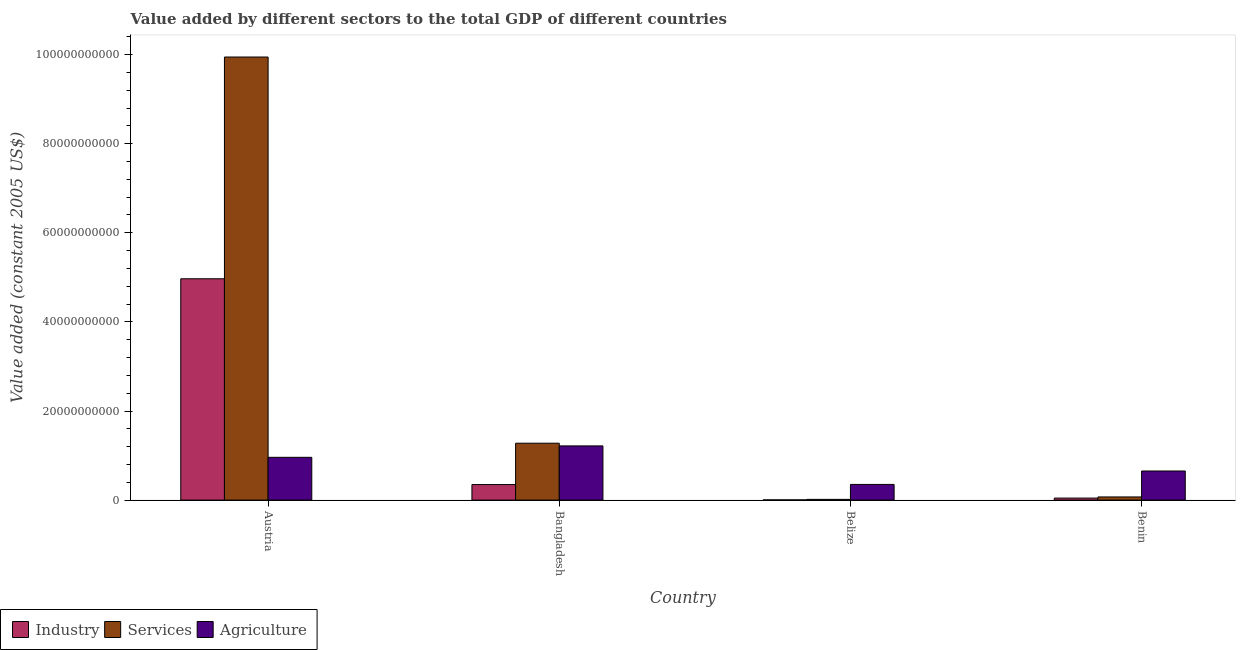Are the number of bars per tick equal to the number of legend labels?
Make the answer very short. Yes. How many bars are there on the 1st tick from the right?
Your answer should be very brief. 3. In how many cases, is the number of bars for a given country not equal to the number of legend labels?
Give a very brief answer. 0. What is the value added by agricultural sector in Austria?
Your answer should be compact. 9.60e+09. Across all countries, what is the maximum value added by industrial sector?
Your answer should be very brief. 4.97e+1. Across all countries, what is the minimum value added by services?
Ensure brevity in your answer.  1.61e+08. In which country was the value added by agricultural sector minimum?
Offer a very short reply. Belize. What is the total value added by agricultural sector in the graph?
Ensure brevity in your answer.  3.18e+1. What is the difference between the value added by agricultural sector in Bangladesh and that in Belize?
Provide a short and direct response. 8.64e+09. What is the difference between the value added by services in Belize and the value added by agricultural sector in Austria?
Offer a very short reply. -9.44e+09. What is the average value added by services per country?
Your response must be concise. 2.83e+1. What is the difference between the value added by industrial sector and value added by agricultural sector in Bangladesh?
Keep it short and to the point. -8.68e+09. In how many countries, is the value added by industrial sector greater than 80000000000 US$?
Provide a succinct answer. 0. What is the ratio of the value added by industrial sector in Belize to that in Benin?
Provide a short and direct response. 0.1. Is the value added by services in Austria less than that in Bangladesh?
Provide a succinct answer. No. Is the difference between the value added by services in Austria and Benin greater than the difference between the value added by industrial sector in Austria and Benin?
Provide a short and direct response. Yes. What is the difference between the highest and the second highest value added by agricultural sector?
Keep it short and to the point. 2.56e+09. What is the difference between the highest and the lowest value added by services?
Ensure brevity in your answer.  9.93e+1. Is the sum of the value added by services in Austria and Benin greater than the maximum value added by agricultural sector across all countries?
Keep it short and to the point. Yes. What does the 3rd bar from the left in Austria represents?
Give a very brief answer. Agriculture. What does the 1st bar from the right in Austria represents?
Give a very brief answer. Agriculture. Is it the case that in every country, the sum of the value added by industrial sector and value added by services is greater than the value added by agricultural sector?
Your response must be concise. No. How many bars are there?
Your response must be concise. 12. Are the values on the major ticks of Y-axis written in scientific E-notation?
Make the answer very short. No. Does the graph contain any zero values?
Ensure brevity in your answer.  No. Where does the legend appear in the graph?
Offer a very short reply. Bottom left. How many legend labels are there?
Your answer should be compact. 3. How are the legend labels stacked?
Offer a very short reply. Horizontal. What is the title of the graph?
Your response must be concise. Value added by different sectors to the total GDP of different countries. What is the label or title of the X-axis?
Your answer should be very brief. Country. What is the label or title of the Y-axis?
Ensure brevity in your answer.  Value added (constant 2005 US$). What is the Value added (constant 2005 US$) in Industry in Austria?
Provide a short and direct response. 4.97e+1. What is the Value added (constant 2005 US$) in Services in Austria?
Your answer should be very brief. 9.95e+1. What is the Value added (constant 2005 US$) in Agriculture in Austria?
Keep it short and to the point. 9.60e+09. What is the Value added (constant 2005 US$) in Industry in Bangladesh?
Offer a terse response. 3.48e+09. What is the Value added (constant 2005 US$) of Services in Bangladesh?
Keep it short and to the point. 1.28e+1. What is the Value added (constant 2005 US$) in Agriculture in Bangladesh?
Make the answer very short. 1.22e+1. What is the Value added (constant 2005 US$) in Industry in Belize?
Your answer should be very brief. 4.64e+07. What is the Value added (constant 2005 US$) of Services in Belize?
Make the answer very short. 1.61e+08. What is the Value added (constant 2005 US$) in Agriculture in Belize?
Ensure brevity in your answer.  3.52e+09. What is the Value added (constant 2005 US$) in Industry in Benin?
Make the answer very short. 4.52e+08. What is the Value added (constant 2005 US$) of Services in Benin?
Provide a succinct answer. 7.09e+08. What is the Value added (constant 2005 US$) in Agriculture in Benin?
Offer a terse response. 6.53e+09. Across all countries, what is the maximum Value added (constant 2005 US$) of Industry?
Offer a very short reply. 4.97e+1. Across all countries, what is the maximum Value added (constant 2005 US$) in Services?
Your answer should be very brief. 9.95e+1. Across all countries, what is the maximum Value added (constant 2005 US$) of Agriculture?
Give a very brief answer. 1.22e+1. Across all countries, what is the minimum Value added (constant 2005 US$) in Industry?
Your answer should be compact. 4.64e+07. Across all countries, what is the minimum Value added (constant 2005 US$) in Services?
Offer a terse response. 1.61e+08. Across all countries, what is the minimum Value added (constant 2005 US$) in Agriculture?
Make the answer very short. 3.52e+09. What is the total Value added (constant 2005 US$) of Industry in the graph?
Keep it short and to the point. 5.37e+1. What is the total Value added (constant 2005 US$) in Services in the graph?
Provide a succinct answer. 1.13e+11. What is the total Value added (constant 2005 US$) of Agriculture in the graph?
Keep it short and to the point. 3.18e+1. What is the difference between the Value added (constant 2005 US$) of Industry in Austria and that in Bangladesh?
Ensure brevity in your answer.  4.62e+1. What is the difference between the Value added (constant 2005 US$) in Services in Austria and that in Bangladesh?
Provide a short and direct response. 8.67e+1. What is the difference between the Value added (constant 2005 US$) in Agriculture in Austria and that in Bangladesh?
Offer a very short reply. -2.56e+09. What is the difference between the Value added (constant 2005 US$) in Industry in Austria and that in Belize?
Offer a very short reply. 4.96e+1. What is the difference between the Value added (constant 2005 US$) of Services in Austria and that in Belize?
Offer a very short reply. 9.93e+1. What is the difference between the Value added (constant 2005 US$) of Agriculture in Austria and that in Belize?
Ensure brevity in your answer.  6.08e+09. What is the difference between the Value added (constant 2005 US$) of Industry in Austria and that in Benin?
Your response must be concise. 4.92e+1. What is the difference between the Value added (constant 2005 US$) of Services in Austria and that in Benin?
Make the answer very short. 9.87e+1. What is the difference between the Value added (constant 2005 US$) of Agriculture in Austria and that in Benin?
Offer a very short reply. 3.07e+09. What is the difference between the Value added (constant 2005 US$) in Industry in Bangladesh and that in Belize?
Provide a short and direct response. 3.44e+09. What is the difference between the Value added (constant 2005 US$) of Services in Bangladesh and that in Belize?
Keep it short and to the point. 1.26e+1. What is the difference between the Value added (constant 2005 US$) of Agriculture in Bangladesh and that in Belize?
Ensure brevity in your answer.  8.64e+09. What is the difference between the Value added (constant 2005 US$) in Industry in Bangladesh and that in Benin?
Provide a succinct answer. 3.03e+09. What is the difference between the Value added (constant 2005 US$) of Services in Bangladesh and that in Benin?
Ensure brevity in your answer.  1.21e+1. What is the difference between the Value added (constant 2005 US$) of Agriculture in Bangladesh and that in Benin?
Provide a succinct answer. 5.63e+09. What is the difference between the Value added (constant 2005 US$) of Industry in Belize and that in Benin?
Provide a succinct answer. -4.05e+08. What is the difference between the Value added (constant 2005 US$) of Services in Belize and that in Benin?
Keep it short and to the point. -5.48e+08. What is the difference between the Value added (constant 2005 US$) in Agriculture in Belize and that in Benin?
Provide a succinct answer. -3.01e+09. What is the difference between the Value added (constant 2005 US$) of Industry in Austria and the Value added (constant 2005 US$) of Services in Bangladesh?
Offer a very short reply. 3.69e+1. What is the difference between the Value added (constant 2005 US$) of Industry in Austria and the Value added (constant 2005 US$) of Agriculture in Bangladesh?
Offer a terse response. 3.75e+1. What is the difference between the Value added (constant 2005 US$) of Services in Austria and the Value added (constant 2005 US$) of Agriculture in Bangladesh?
Your response must be concise. 8.73e+1. What is the difference between the Value added (constant 2005 US$) of Industry in Austria and the Value added (constant 2005 US$) of Services in Belize?
Keep it short and to the point. 4.95e+1. What is the difference between the Value added (constant 2005 US$) in Industry in Austria and the Value added (constant 2005 US$) in Agriculture in Belize?
Your answer should be very brief. 4.62e+1. What is the difference between the Value added (constant 2005 US$) of Services in Austria and the Value added (constant 2005 US$) of Agriculture in Belize?
Give a very brief answer. 9.59e+1. What is the difference between the Value added (constant 2005 US$) of Industry in Austria and the Value added (constant 2005 US$) of Services in Benin?
Your answer should be compact. 4.90e+1. What is the difference between the Value added (constant 2005 US$) in Industry in Austria and the Value added (constant 2005 US$) in Agriculture in Benin?
Provide a succinct answer. 4.31e+1. What is the difference between the Value added (constant 2005 US$) in Services in Austria and the Value added (constant 2005 US$) in Agriculture in Benin?
Offer a very short reply. 9.29e+1. What is the difference between the Value added (constant 2005 US$) in Industry in Bangladesh and the Value added (constant 2005 US$) in Services in Belize?
Keep it short and to the point. 3.32e+09. What is the difference between the Value added (constant 2005 US$) of Industry in Bangladesh and the Value added (constant 2005 US$) of Agriculture in Belize?
Your answer should be very brief. -3.68e+07. What is the difference between the Value added (constant 2005 US$) in Services in Bangladesh and the Value added (constant 2005 US$) in Agriculture in Belize?
Your answer should be very brief. 9.25e+09. What is the difference between the Value added (constant 2005 US$) of Industry in Bangladesh and the Value added (constant 2005 US$) of Services in Benin?
Offer a terse response. 2.78e+09. What is the difference between the Value added (constant 2005 US$) in Industry in Bangladesh and the Value added (constant 2005 US$) in Agriculture in Benin?
Offer a terse response. -3.05e+09. What is the difference between the Value added (constant 2005 US$) in Services in Bangladesh and the Value added (constant 2005 US$) in Agriculture in Benin?
Provide a succinct answer. 6.24e+09. What is the difference between the Value added (constant 2005 US$) of Industry in Belize and the Value added (constant 2005 US$) of Services in Benin?
Your answer should be compact. -6.63e+08. What is the difference between the Value added (constant 2005 US$) of Industry in Belize and the Value added (constant 2005 US$) of Agriculture in Benin?
Offer a terse response. -6.49e+09. What is the difference between the Value added (constant 2005 US$) of Services in Belize and the Value added (constant 2005 US$) of Agriculture in Benin?
Ensure brevity in your answer.  -6.37e+09. What is the average Value added (constant 2005 US$) of Industry per country?
Provide a succinct answer. 1.34e+1. What is the average Value added (constant 2005 US$) of Services per country?
Give a very brief answer. 2.83e+1. What is the average Value added (constant 2005 US$) of Agriculture per country?
Your answer should be very brief. 7.96e+09. What is the difference between the Value added (constant 2005 US$) of Industry and Value added (constant 2005 US$) of Services in Austria?
Offer a very short reply. -4.98e+1. What is the difference between the Value added (constant 2005 US$) in Industry and Value added (constant 2005 US$) in Agriculture in Austria?
Provide a succinct answer. 4.01e+1. What is the difference between the Value added (constant 2005 US$) of Services and Value added (constant 2005 US$) of Agriculture in Austria?
Give a very brief answer. 8.99e+1. What is the difference between the Value added (constant 2005 US$) of Industry and Value added (constant 2005 US$) of Services in Bangladesh?
Your response must be concise. -9.28e+09. What is the difference between the Value added (constant 2005 US$) in Industry and Value added (constant 2005 US$) in Agriculture in Bangladesh?
Offer a very short reply. -8.68e+09. What is the difference between the Value added (constant 2005 US$) of Services and Value added (constant 2005 US$) of Agriculture in Bangladesh?
Give a very brief answer. 6.04e+08. What is the difference between the Value added (constant 2005 US$) of Industry and Value added (constant 2005 US$) of Services in Belize?
Your answer should be very brief. -1.14e+08. What is the difference between the Value added (constant 2005 US$) of Industry and Value added (constant 2005 US$) of Agriculture in Belize?
Keep it short and to the point. -3.47e+09. What is the difference between the Value added (constant 2005 US$) in Services and Value added (constant 2005 US$) in Agriculture in Belize?
Your response must be concise. -3.36e+09. What is the difference between the Value added (constant 2005 US$) in Industry and Value added (constant 2005 US$) in Services in Benin?
Your answer should be compact. -2.58e+08. What is the difference between the Value added (constant 2005 US$) in Industry and Value added (constant 2005 US$) in Agriculture in Benin?
Provide a short and direct response. -6.08e+09. What is the difference between the Value added (constant 2005 US$) of Services and Value added (constant 2005 US$) of Agriculture in Benin?
Provide a succinct answer. -5.82e+09. What is the ratio of the Value added (constant 2005 US$) of Industry in Austria to that in Bangladesh?
Provide a short and direct response. 14.26. What is the ratio of the Value added (constant 2005 US$) in Services in Austria to that in Bangladesh?
Offer a terse response. 7.79. What is the ratio of the Value added (constant 2005 US$) in Agriculture in Austria to that in Bangladesh?
Offer a very short reply. 0.79. What is the ratio of the Value added (constant 2005 US$) of Industry in Austria to that in Belize?
Make the answer very short. 1071.1. What is the ratio of the Value added (constant 2005 US$) of Services in Austria to that in Belize?
Provide a succinct answer. 618.78. What is the ratio of the Value added (constant 2005 US$) of Agriculture in Austria to that in Belize?
Offer a very short reply. 2.73. What is the ratio of the Value added (constant 2005 US$) in Industry in Austria to that in Benin?
Offer a terse response. 110.02. What is the ratio of the Value added (constant 2005 US$) of Services in Austria to that in Benin?
Make the answer very short. 140.25. What is the ratio of the Value added (constant 2005 US$) of Agriculture in Austria to that in Benin?
Offer a very short reply. 1.47. What is the ratio of the Value added (constant 2005 US$) of Industry in Bangladesh to that in Belize?
Offer a very short reply. 75.12. What is the ratio of the Value added (constant 2005 US$) in Services in Bangladesh to that in Belize?
Your response must be concise. 79.44. What is the ratio of the Value added (constant 2005 US$) in Agriculture in Bangladesh to that in Belize?
Your answer should be very brief. 3.45. What is the ratio of the Value added (constant 2005 US$) of Industry in Bangladesh to that in Benin?
Provide a short and direct response. 7.72. What is the ratio of the Value added (constant 2005 US$) in Services in Bangladesh to that in Benin?
Provide a short and direct response. 18.01. What is the ratio of the Value added (constant 2005 US$) in Agriculture in Bangladesh to that in Benin?
Your answer should be very brief. 1.86. What is the ratio of the Value added (constant 2005 US$) in Industry in Belize to that in Benin?
Your response must be concise. 0.1. What is the ratio of the Value added (constant 2005 US$) in Services in Belize to that in Benin?
Your answer should be very brief. 0.23. What is the ratio of the Value added (constant 2005 US$) of Agriculture in Belize to that in Benin?
Your answer should be compact. 0.54. What is the difference between the highest and the second highest Value added (constant 2005 US$) in Industry?
Make the answer very short. 4.62e+1. What is the difference between the highest and the second highest Value added (constant 2005 US$) in Services?
Offer a very short reply. 8.67e+1. What is the difference between the highest and the second highest Value added (constant 2005 US$) of Agriculture?
Your response must be concise. 2.56e+09. What is the difference between the highest and the lowest Value added (constant 2005 US$) of Industry?
Keep it short and to the point. 4.96e+1. What is the difference between the highest and the lowest Value added (constant 2005 US$) in Services?
Give a very brief answer. 9.93e+1. What is the difference between the highest and the lowest Value added (constant 2005 US$) of Agriculture?
Offer a very short reply. 8.64e+09. 